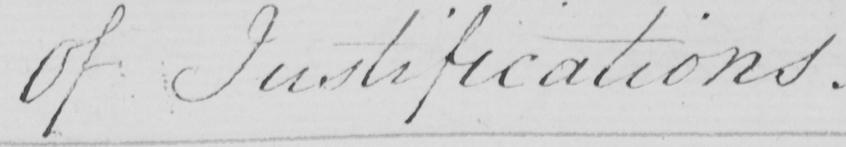What is written in this line of handwriting? Of Justifications . 